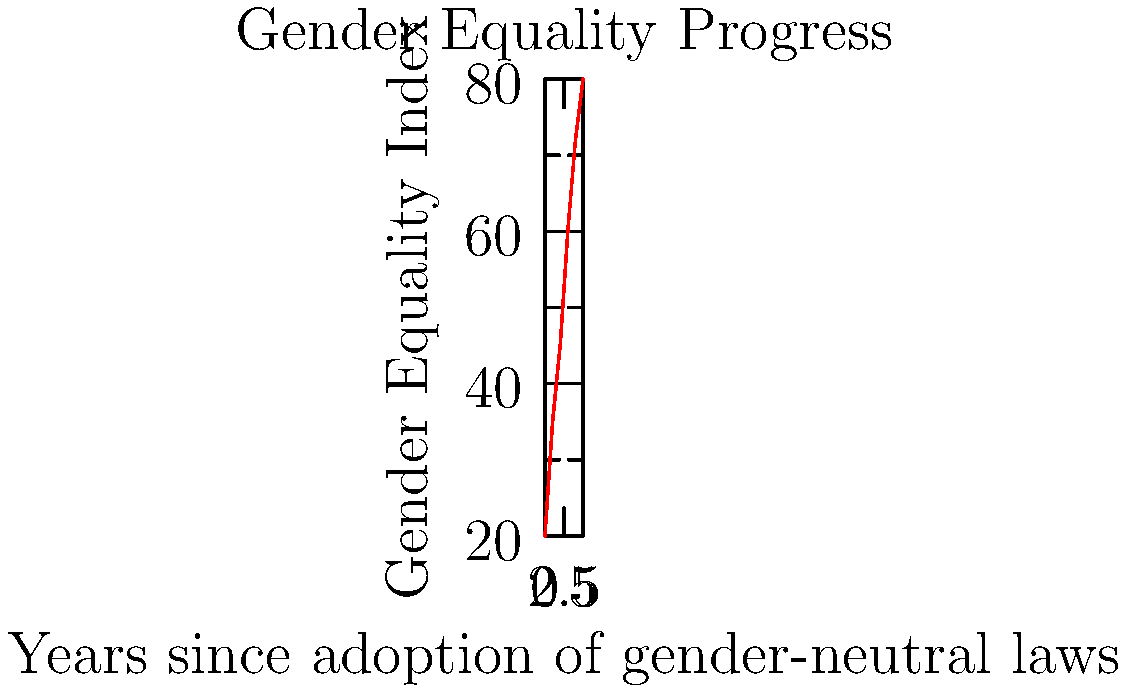Based on the line graph showing the correlation between the adoption of gender-neutral laws and the Gender Equality Index, what is the average rate of increase in the Gender Equality Index per year during the first five years after the implementation of gender-neutral laws? To calculate the average rate of increase in the Gender Equality Index per year:

1. Identify the initial and final values:
   Initial value (Year 0): 20
   Final value (Year 5): 80

2. Calculate the total increase:
   $80 - 20 = 60$

3. Divide the total increase by the number of years:
   $\frac{60}{5} = 12$

Therefore, the average rate of increase in the Gender Equality Index is 12 points per year during the first five years after the implementation of gender-neutral laws.
Answer: 12 points per year 